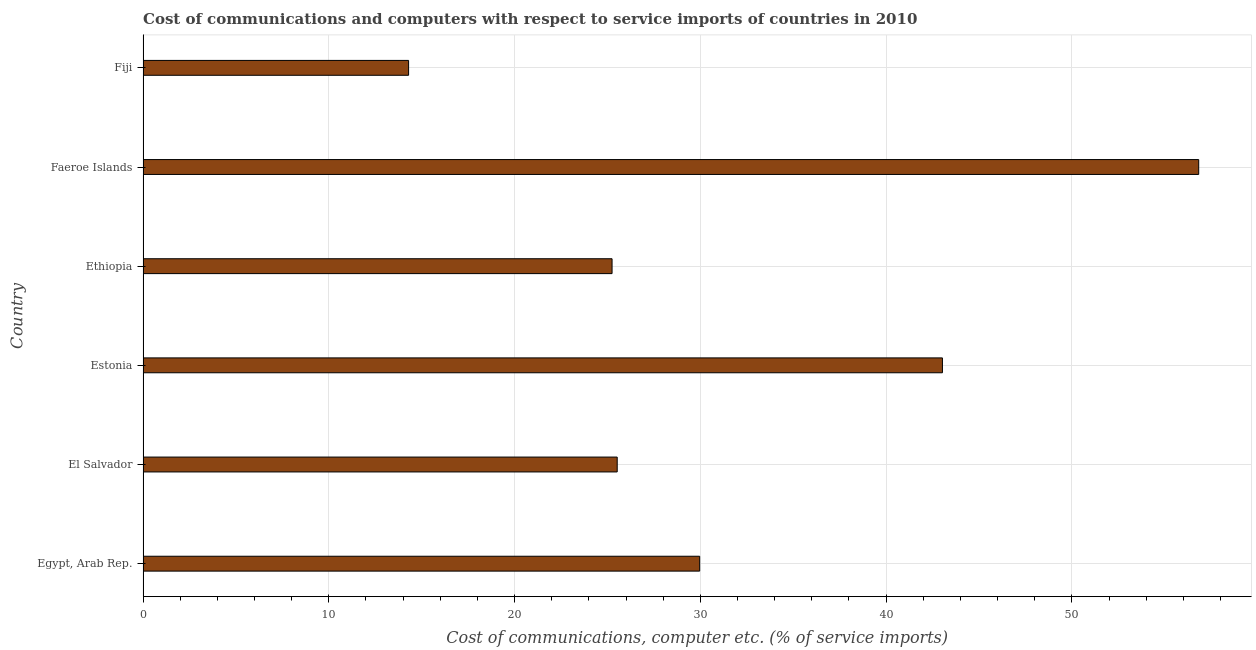Does the graph contain grids?
Your answer should be compact. Yes. What is the title of the graph?
Provide a short and direct response. Cost of communications and computers with respect to service imports of countries in 2010. What is the label or title of the X-axis?
Provide a succinct answer. Cost of communications, computer etc. (% of service imports). What is the cost of communications and computer in El Salvador?
Offer a very short reply. 25.52. Across all countries, what is the maximum cost of communications and computer?
Provide a short and direct response. 56.83. Across all countries, what is the minimum cost of communications and computer?
Provide a short and direct response. 14.29. In which country was the cost of communications and computer maximum?
Provide a short and direct response. Faeroe Islands. In which country was the cost of communications and computer minimum?
Your answer should be very brief. Fiji. What is the sum of the cost of communications and computer?
Offer a very short reply. 194.89. What is the difference between the cost of communications and computer in Egypt, Arab Rep. and Fiji?
Make the answer very short. 15.67. What is the average cost of communications and computer per country?
Give a very brief answer. 32.48. What is the median cost of communications and computer?
Your answer should be compact. 27.74. What is the ratio of the cost of communications and computer in El Salvador to that in Faeroe Islands?
Your answer should be very brief. 0.45. Is the cost of communications and computer in Egypt, Arab Rep. less than that in Ethiopia?
Give a very brief answer. No. Is the difference between the cost of communications and computer in Ethiopia and Fiji greater than the difference between any two countries?
Provide a succinct answer. No. What is the difference between the highest and the second highest cost of communications and computer?
Provide a short and direct response. 13.8. What is the difference between the highest and the lowest cost of communications and computer?
Provide a succinct answer. 42.53. How many bars are there?
Provide a short and direct response. 6. How many countries are there in the graph?
Offer a terse response. 6. What is the difference between two consecutive major ticks on the X-axis?
Give a very brief answer. 10. Are the values on the major ticks of X-axis written in scientific E-notation?
Provide a short and direct response. No. What is the Cost of communications, computer etc. (% of service imports) in Egypt, Arab Rep.?
Provide a short and direct response. 29.96. What is the Cost of communications, computer etc. (% of service imports) of El Salvador?
Keep it short and to the point. 25.52. What is the Cost of communications, computer etc. (% of service imports) in Estonia?
Ensure brevity in your answer.  43.03. What is the Cost of communications, computer etc. (% of service imports) in Ethiopia?
Your answer should be compact. 25.25. What is the Cost of communications, computer etc. (% of service imports) in Faeroe Islands?
Your answer should be very brief. 56.83. What is the Cost of communications, computer etc. (% of service imports) in Fiji?
Keep it short and to the point. 14.29. What is the difference between the Cost of communications, computer etc. (% of service imports) in Egypt, Arab Rep. and El Salvador?
Make the answer very short. 4.44. What is the difference between the Cost of communications, computer etc. (% of service imports) in Egypt, Arab Rep. and Estonia?
Offer a terse response. -13.07. What is the difference between the Cost of communications, computer etc. (% of service imports) in Egypt, Arab Rep. and Ethiopia?
Offer a very short reply. 4.72. What is the difference between the Cost of communications, computer etc. (% of service imports) in Egypt, Arab Rep. and Faeroe Islands?
Your answer should be very brief. -26.86. What is the difference between the Cost of communications, computer etc. (% of service imports) in Egypt, Arab Rep. and Fiji?
Provide a short and direct response. 15.67. What is the difference between the Cost of communications, computer etc. (% of service imports) in El Salvador and Estonia?
Keep it short and to the point. -17.51. What is the difference between the Cost of communications, computer etc. (% of service imports) in El Salvador and Ethiopia?
Make the answer very short. 0.28. What is the difference between the Cost of communications, computer etc. (% of service imports) in El Salvador and Faeroe Islands?
Your answer should be compact. -31.3. What is the difference between the Cost of communications, computer etc. (% of service imports) in El Salvador and Fiji?
Your answer should be very brief. 11.23. What is the difference between the Cost of communications, computer etc. (% of service imports) in Estonia and Ethiopia?
Give a very brief answer. 17.78. What is the difference between the Cost of communications, computer etc. (% of service imports) in Estonia and Faeroe Islands?
Your response must be concise. -13.8. What is the difference between the Cost of communications, computer etc. (% of service imports) in Estonia and Fiji?
Your response must be concise. 28.74. What is the difference between the Cost of communications, computer etc. (% of service imports) in Ethiopia and Faeroe Islands?
Give a very brief answer. -31.58. What is the difference between the Cost of communications, computer etc. (% of service imports) in Ethiopia and Fiji?
Your answer should be compact. 10.95. What is the difference between the Cost of communications, computer etc. (% of service imports) in Faeroe Islands and Fiji?
Your answer should be compact. 42.53. What is the ratio of the Cost of communications, computer etc. (% of service imports) in Egypt, Arab Rep. to that in El Salvador?
Ensure brevity in your answer.  1.17. What is the ratio of the Cost of communications, computer etc. (% of service imports) in Egypt, Arab Rep. to that in Estonia?
Your answer should be very brief. 0.7. What is the ratio of the Cost of communications, computer etc. (% of service imports) in Egypt, Arab Rep. to that in Ethiopia?
Provide a short and direct response. 1.19. What is the ratio of the Cost of communications, computer etc. (% of service imports) in Egypt, Arab Rep. to that in Faeroe Islands?
Ensure brevity in your answer.  0.53. What is the ratio of the Cost of communications, computer etc. (% of service imports) in Egypt, Arab Rep. to that in Fiji?
Give a very brief answer. 2.1. What is the ratio of the Cost of communications, computer etc. (% of service imports) in El Salvador to that in Estonia?
Keep it short and to the point. 0.59. What is the ratio of the Cost of communications, computer etc. (% of service imports) in El Salvador to that in Faeroe Islands?
Ensure brevity in your answer.  0.45. What is the ratio of the Cost of communications, computer etc. (% of service imports) in El Salvador to that in Fiji?
Your answer should be very brief. 1.79. What is the ratio of the Cost of communications, computer etc. (% of service imports) in Estonia to that in Ethiopia?
Offer a very short reply. 1.7. What is the ratio of the Cost of communications, computer etc. (% of service imports) in Estonia to that in Faeroe Islands?
Offer a terse response. 0.76. What is the ratio of the Cost of communications, computer etc. (% of service imports) in Estonia to that in Fiji?
Your answer should be very brief. 3.01. What is the ratio of the Cost of communications, computer etc. (% of service imports) in Ethiopia to that in Faeroe Islands?
Your response must be concise. 0.44. What is the ratio of the Cost of communications, computer etc. (% of service imports) in Ethiopia to that in Fiji?
Provide a short and direct response. 1.77. What is the ratio of the Cost of communications, computer etc. (% of service imports) in Faeroe Islands to that in Fiji?
Offer a very short reply. 3.98. 